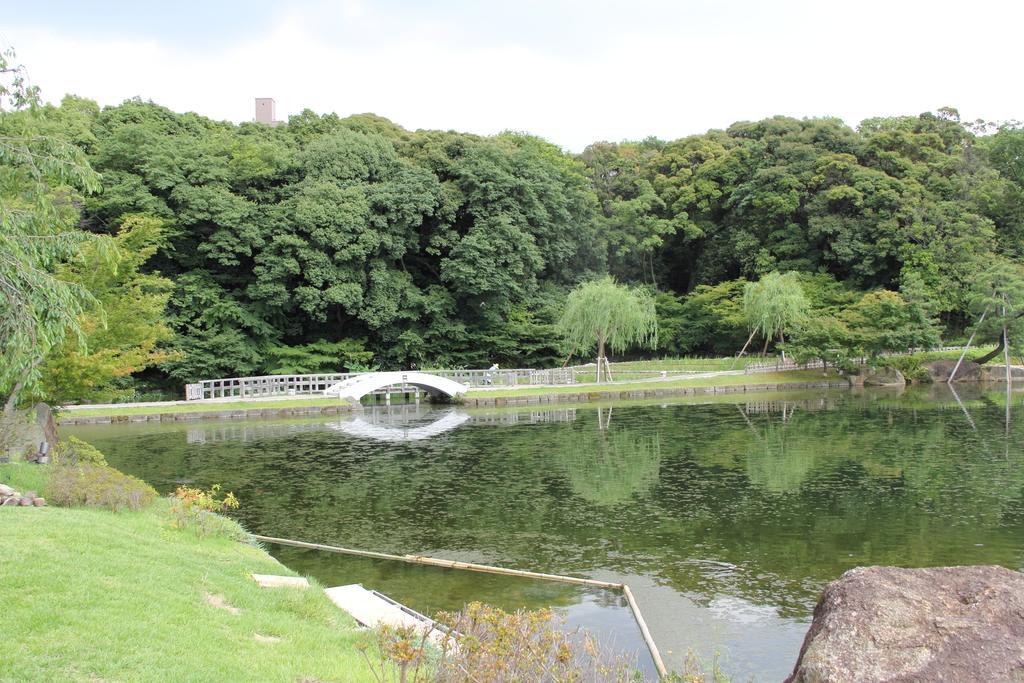Could you give a brief overview of what you see in this image? In this image there is lake, on that lake there is a bridge the lake is surrounded with trees in the background there is a sky. 